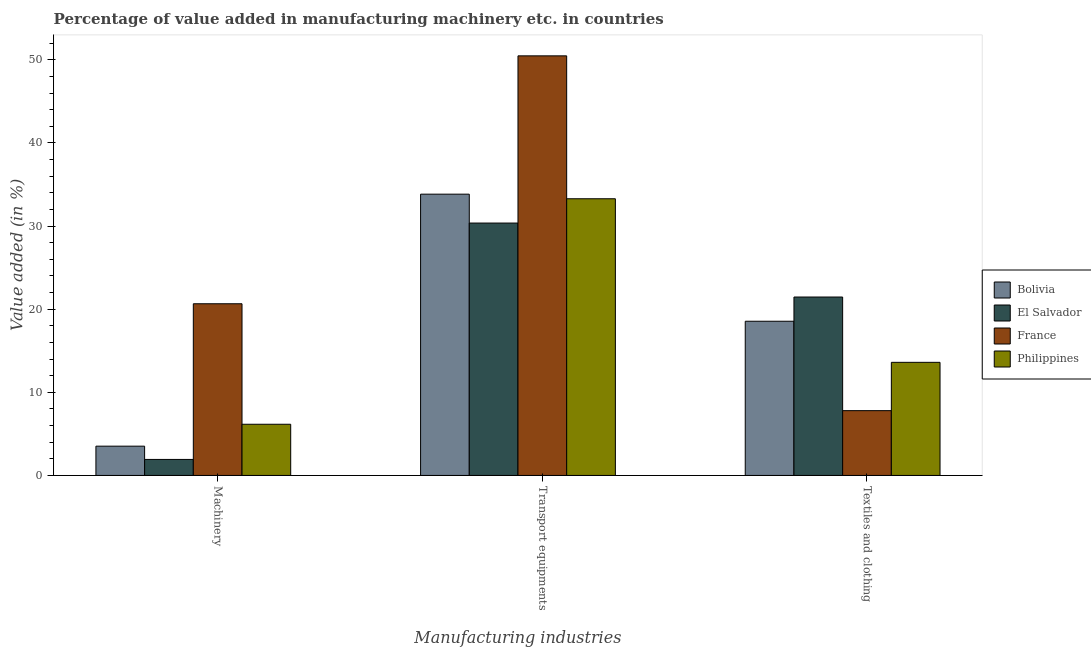How many groups of bars are there?
Your answer should be very brief. 3. Are the number of bars on each tick of the X-axis equal?
Your answer should be very brief. Yes. How many bars are there on the 3rd tick from the left?
Make the answer very short. 4. How many bars are there on the 3rd tick from the right?
Offer a terse response. 4. What is the label of the 2nd group of bars from the left?
Your answer should be compact. Transport equipments. What is the value added in manufacturing machinery in Philippines?
Provide a succinct answer. 6.16. Across all countries, what is the maximum value added in manufacturing machinery?
Offer a very short reply. 20.66. Across all countries, what is the minimum value added in manufacturing machinery?
Offer a terse response. 1.93. In which country was the value added in manufacturing transport equipments maximum?
Your response must be concise. France. In which country was the value added in manufacturing transport equipments minimum?
Provide a succinct answer. El Salvador. What is the total value added in manufacturing machinery in the graph?
Give a very brief answer. 32.26. What is the difference between the value added in manufacturing textile and clothing in El Salvador and that in Bolivia?
Keep it short and to the point. 2.91. What is the difference between the value added in manufacturing transport equipments in Philippines and the value added in manufacturing textile and clothing in El Salvador?
Provide a succinct answer. 11.82. What is the average value added in manufacturing textile and clothing per country?
Your response must be concise. 15.36. What is the difference between the value added in manufacturing textile and clothing and value added in manufacturing transport equipments in El Salvador?
Your answer should be compact. -8.9. In how many countries, is the value added in manufacturing machinery greater than 14 %?
Make the answer very short. 1. What is the ratio of the value added in manufacturing machinery in El Salvador to that in Bolivia?
Your answer should be very brief. 0.55. Is the value added in manufacturing machinery in France less than that in Bolivia?
Offer a terse response. No. What is the difference between the highest and the second highest value added in manufacturing machinery?
Ensure brevity in your answer.  14.5. What is the difference between the highest and the lowest value added in manufacturing machinery?
Offer a terse response. 18.73. What does the 3rd bar from the left in Machinery represents?
Give a very brief answer. France. What does the 4th bar from the right in Transport equipments represents?
Provide a succinct answer. Bolivia. Are all the bars in the graph horizontal?
Make the answer very short. No. What is the difference between two consecutive major ticks on the Y-axis?
Make the answer very short. 10. Are the values on the major ticks of Y-axis written in scientific E-notation?
Your answer should be compact. No. What is the title of the graph?
Give a very brief answer. Percentage of value added in manufacturing machinery etc. in countries. Does "Egypt, Arab Rep." appear as one of the legend labels in the graph?
Offer a very short reply. No. What is the label or title of the X-axis?
Provide a succinct answer. Manufacturing industries. What is the label or title of the Y-axis?
Your response must be concise. Value added (in %). What is the Value added (in %) of Bolivia in Machinery?
Keep it short and to the point. 3.52. What is the Value added (in %) of El Salvador in Machinery?
Offer a terse response. 1.93. What is the Value added (in %) in France in Machinery?
Give a very brief answer. 20.66. What is the Value added (in %) in Philippines in Machinery?
Keep it short and to the point. 6.16. What is the Value added (in %) in Bolivia in Transport equipments?
Provide a short and direct response. 33.84. What is the Value added (in %) of El Salvador in Transport equipments?
Ensure brevity in your answer.  30.37. What is the Value added (in %) of France in Transport equipments?
Your response must be concise. 50.49. What is the Value added (in %) in Philippines in Transport equipments?
Provide a succinct answer. 33.29. What is the Value added (in %) of Bolivia in Textiles and clothing?
Offer a very short reply. 18.55. What is the Value added (in %) of El Salvador in Textiles and clothing?
Ensure brevity in your answer.  21.47. What is the Value added (in %) in France in Textiles and clothing?
Provide a short and direct response. 7.8. What is the Value added (in %) of Philippines in Textiles and clothing?
Provide a succinct answer. 13.61. Across all Manufacturing industries, what is the maximum Value added (in %) in Bolivia?
Make the answer very short. 33.84. Across all Manufacturing industries, what is the maximum Value added (in %) of El Salvador?
Offer a terse response. 30.37. Across all Manufacturing industries, what is the maximum Value added (in %) in France?
Provide a short and direct response. 50.49. Across all Manufacturing industries, what is the maximum Value added (in %) of Philippines?
Provide a short and direct response. 33.29. Across all Manufacturing industries, what is the minimum Value added (in %) of Bolivia?
Provide a succinct answer. 3.52. Across all Manufacturing industries, what is the minimum Value added (in %) of El Salvador?
Ensure brevity in your answer.  1.93. Across all Manufacturing industries, what is the minimum Value added (in %) of France?
Keep it short and to the point. 7.8. Across all Manufacturing industries, what is the minimum Value added (in %) of Philippines?
Your response must be concise. 6.16. What is the total Value added (in %) in Bolivia in the graph?
Give a very brief answer. 55.92. What is the total Value added (in %) of El Salvador in the graph?
Offer a terse response. 53.76. What is the total Value added (in %) of France in the graph?
Provide a short and direct response. 78.94. What is the total Value added (in %) in Philippines in the graph?
Your answer should be compact. 53.06. What is the difference between the Value added (in %) in Bolivia in Machinery and that in Transport equipments?
Provide a short and direct response. -30.32. What is the difference between the Value added (in %) of El Salvador in Machinery and that in Transport equipments?
Give a very brief answer. -28.44. What is the difference between the Value added (in %) of France in Machinery and that in Transport equipments?
Provide a short and direct response. -29.83. What is the difference between the Value added (in %) in Philippines in Machinery and that in Transport equipments?
Your answer should be compact. -27.13. What is the difference between the Value added (in %) of Bolivia in Machinery and that in Textiles and clothing?
Provide a succinct answer. -15.03. What is the difference between the Value added (in %) in El Salvador in Machinery and that in Textiles and clothing?
Offer a terse response. -19.54. What is the difference between the Value added (in %) in France in Machinery and that in Textiles and clothing?
Keep it short and to the point. 12.86. What is the difference between the Value added (in %) in Philippines in Machinery and that in Textiles and clothing?
Your answer should be very brief. -7.45. What is the difference between the Value added (in %) of Bolivia in Transport equipments and that in Textiles and clothing?
Ensure brevity in your answer.  15.29. What is the difference between the Value added (in %) in El Salvador in Transport equipments and that in Textiles and clothing?
Your answer should be very brief. 8.9. What is the difference between the Value added (in %) of France in Transport equipments and that in Textiles and clothing?
Provide a succinct answer. 42.69. What is the difference between the Value added (in %) of Philippines in Transport equipments and that in Textiles and clothing?
Ensure brevity in your answer.  19.68. What is the difference between the Value added (in %) in Bolivia in Machinery and the Value added (in %) in El Salvador in Transport equipments?
Provide a succinct answer. -26.84. What is the difference between the Value added (in %) in Bolivia in Machinery and the Value added (in %) in France in Transport equipments?
Make the answer very short. -46.96. What is the difference between the Value added (in %) of Bolivia in Machinery and the Value added (in %) of Philippines in Transport equipments?
Your response must be concise. -29.77. What is the difference between the Value added (in %) of El Salvador in Machinery and the Value added (in %) of France in Transport equipments?
Make the answer very short. -48.56. What is the difference between the Value added (in %) in El Salvador in Machinery and the Value added (in %) in Philippines in Transport equipments?
Keep it short and to the point. -31.36. What is the difference between the Value added (in %) in France in Machinery and the Value added (in %) in Philippines in Transport equipments?
Your response must be concise. -12.63. What is the difference between the Value added (in %) of Bolivia in Machinery and the Value added (in %) of El Salvador in Textiles and clothing?
Ensure brevity in your answer.  -17.95. What is the difference between the Value added (in %) in Bolivia in Machinery and the Value added (in %) in France in Textiles and clothing?
Make the answer very short. -4.27. What is the difference between the Value added (in %) in Bolivia in Machinery and the Value added (in %) in Philippines in Textiles and clothing?
Make the answer very short. -10.09. What is the difference between the Value added (in %) in El Salvador in Machinery and the Value added (in %) in France in Textiles and clothing?
Your answer should be compact. -5.87. What is the difference between the Value added (in %) in El Salvador in Machinery and the Value added (in %) in Philippines in Textiles and clothing?
Offer a very short reply. -11.68. What is the difference between the Value added (in %) in France in Machinery and the Value added (in %) in Philippines in Textiles and clothing?
Provide a succinct answer. 7.05. What is the difference between the Value added (in %) in Bolivia in Transport equipments and the Value added (in %) in El Salvador in Textiles and clothing?
Keep it short and to the point. 12.38. What is the difference between the Value added (in %) of Bolivia in Transport equipments and the Value added (in %) of France in Textiles and clothing?
Keep it short and to the point. 26.05. What is the difference between the Value added (in %) in Bolivia in Transport equipments and the Value added (in %) in Philippines in Textiles and clothing?
Provide a succinct answer. 20.23. What is the difference between the Value added (in %) of El Salvador in Transport equipments and the Value added (in %) of France in Textiles and clothing?
Provide a succinct answer. 22.57. What is the difference between the Value added (in %) in El Salvador in Transport equipments and the Value added (in %) in Philippines in Textiles and clothing?
Offer a very short reply. 16.76. What is the difference between the Value added (in %) of France in Transport equipments and the Value added (in %) of Philippines in Textiles and clothing?
Provide a short and direct response. 36.88. What is the average Value added (in %) of Bolivia per Manufacturing industries?
Your answer should be compact. 18.64. What is the average Value added (in %) of El Salvador per Manufacturing industries?
Make the answer very short. 17.92. What is the average Value added (in %) of France per Manufacturing industries?
Your response must be concise. 26.31. What is the average Value added (in %) in Philippines per Manufacturing industries?
Offer a terse response. 17.69. What is the difference between the Value added (in %) of Bolivia and Value added (in %) of El Salvador in Machinery?
Give a very brief answer. 1.6. What is the difference between the Value added (in %) in Bolivia and Value added (in %) in France in Machinery?
Keep it short and to the point. -17.14. What is the difference between the Value added (in %) of Bolivia and Value added (in %) of Philippines in Machinery?
Provide a short and direct response. -2.64. What is the difference between the Value added (in %) in El Salvador and Value added (in %) in France in Machinery?
Provide a succinct answer. -18.73. What is the difference between the Value added (in %) of El Salvador and Value added (in %) of Philippines in Machinery?
Provide a short and direct response. -4.23. What is the difference between the Value added (in %) of France and Value added (in %) of Philippines in Machinery?
Your answer should be very brief. 14.5. What is the difference between the Value added (in %) of Bolivia and Value added (in %) of El Salvador in Transport equipments?
Give a very brief answer. 3.48. What is the difference between the Value added (in %) of Bolivia and Value added (in %) of France in Transport equipments?
Give a very brief answer. -16.64. What is the difference between the Value added (in %) of Bolivia and Value added (in %) of Philippines in Transport equipments?
Your answer should be very brief. 0.55. What is the difference between the Value added (in %) in El Salvador and Value added (in %) in France in Transport equipments?
Your answer should be very brief. -20.12. What is the difference between the Value added (in %) of El Salvador and Value added (in %) of Philippines in Transport equipments?
Offer a terse response. -2.92. What is the difference between the Value added (in %) of France and Value added (in %) of Philippines in Transport equipments?
Make the answer very short. 17.19. What is the difference between the Value added (in %) in Bolivia and Value added (in %) in El Salvador in Textiles and clothing?
Provide a succinct answer. -2.92. What is the difference between the Value added (in %) of Bolivia and Value added (in %) of France in Textiles and clothing?
Your response must be concise. 10.76. What is the difference between the Value added (in %) in Bolivia and Value added (in %) in Philippines in Textiles and clothing?
Your answer should be very brief. 4.94. What is the difference between the Value added (in %) of El Salvador and Value added (in %) of France in Textiles and clothing?
Ensure brevity in your answer.  13.67. What is the difference between the Value added (in %) of El Salvador and Value added (in %) of Philippines in Textiles and clothing?
Give a very brief answer. 7.86. What is the difference between the Value added (in %) of France and Value added (in %) of Philippines in Textiles and clothing?
Offer a terse response. -5.81. What is the ratio of the Value added (in %) in Bolivia in Machinery to that in Transport equipments?
Offer a terse response. 0.1. What is the ratio of the Value added (in %) of El Salvador in Machinery to that in Transport equipments?
Your answer should be very brief. 0.06. What is the ratio of the Value added (in %) of France in Machinery to that in Transport equipments?
Keep it short and to the point. 0.41. What is the ratio of the Value added (in %) in Philippines in Machinery to that in Transport equipments?
Make the answer very short. 0.18. What is the ratio of the Value added (in %) of Bolivia in Machinery to that in Textiles and clothing?
Your answer should be compact. 0.19. What is the ratio of the Value added (in %) in El Salvador in Machinery to that in Textiles and clothing?
Your answer should be compact. 0.09. What is the ratio of the Value added (in %) in France in Machinery to that in Textiles and clothing?
Your response must be concise. 2.65. What is the ratio of the Value added (in %) in Philippines in Machinery to that in Textiles and clothing?
Offer a very short reply. 0.45. What is the ratio of the Value added (in %) in Bolivia in Transport equipments to that in Textiles and clothing?
Offer a very short reply. 1.82. What is the ratio of the Value added (in %) in El Salvador in Transport equipments to that in Textiles and clothing?
Give a very brief answer. 1.41. What is the ratio of the Value added (in %) of France in Transport equipments to that in Textiles and clothing?
Ensure brevity in your answer.  6.48. What is the ratio of the Value added (in %) of Philippines in Transport equipments to that in Textiles and clothing?
Provide a short and direct response. 2.45. What is the difference between the highest and the second highest Value added (in %) of Bolivia?
Offer a terse response. 15.29. What is the difference between the highest and the second highest Value added (in %) of El Salvador?
Ensure brevity in your answer.  8.9. What is the difference between the highest and the second highest Value added (in %) of France?
Provide a short and direct response. 29.83. What is the difference between the highest and the second highest Value added (in %) of Philippines?
Ensure brevity in your answer.  19.68. What is the difference between the highest and the lowest Value added (in %) of Bolivia?
Your answer should be very brief. 30.32. What is the difference between the highest and the lowest Value added (in %) of El Salvador?
Ensure brevity in your answer.  28.44. What is the difference between the highest and the lowest Value added (in %) in France?
Provide a short and direct response. 42.69. What is the difference between the highest and the lowest Value added (in %) of Philippines?
Provide a short and direct response. 27.13. 